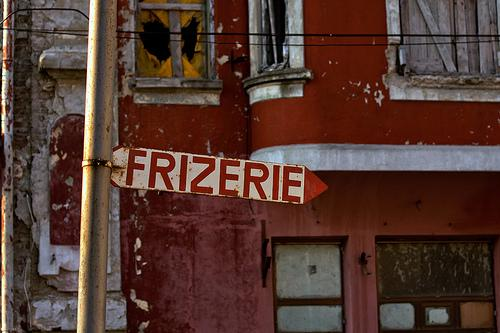Question: what does the sign say?
Choices:
A. FRIZERIE.
B. Stop.
C. Caution.
D. Yield.
Answer with the letter. Answer: A Question: what kind of light is shining?
Choices:
A. Sunlight.
B. Studio lights.
C. Headlights.
D. Table lamps.
Answer with the letter. Answer: A Question: what is the nearest pole made of?
Choices:
A. Wood.
B. PVC pipe.
C. Metal.
D. Rock.
Answer with the letter. Answer: C Question: what two colors are the sign?
Choices:
A. Red and white.
B. Yellow and white.
C. Black and white.
D. Red and blue.
Answer with the letter. Answer: A 